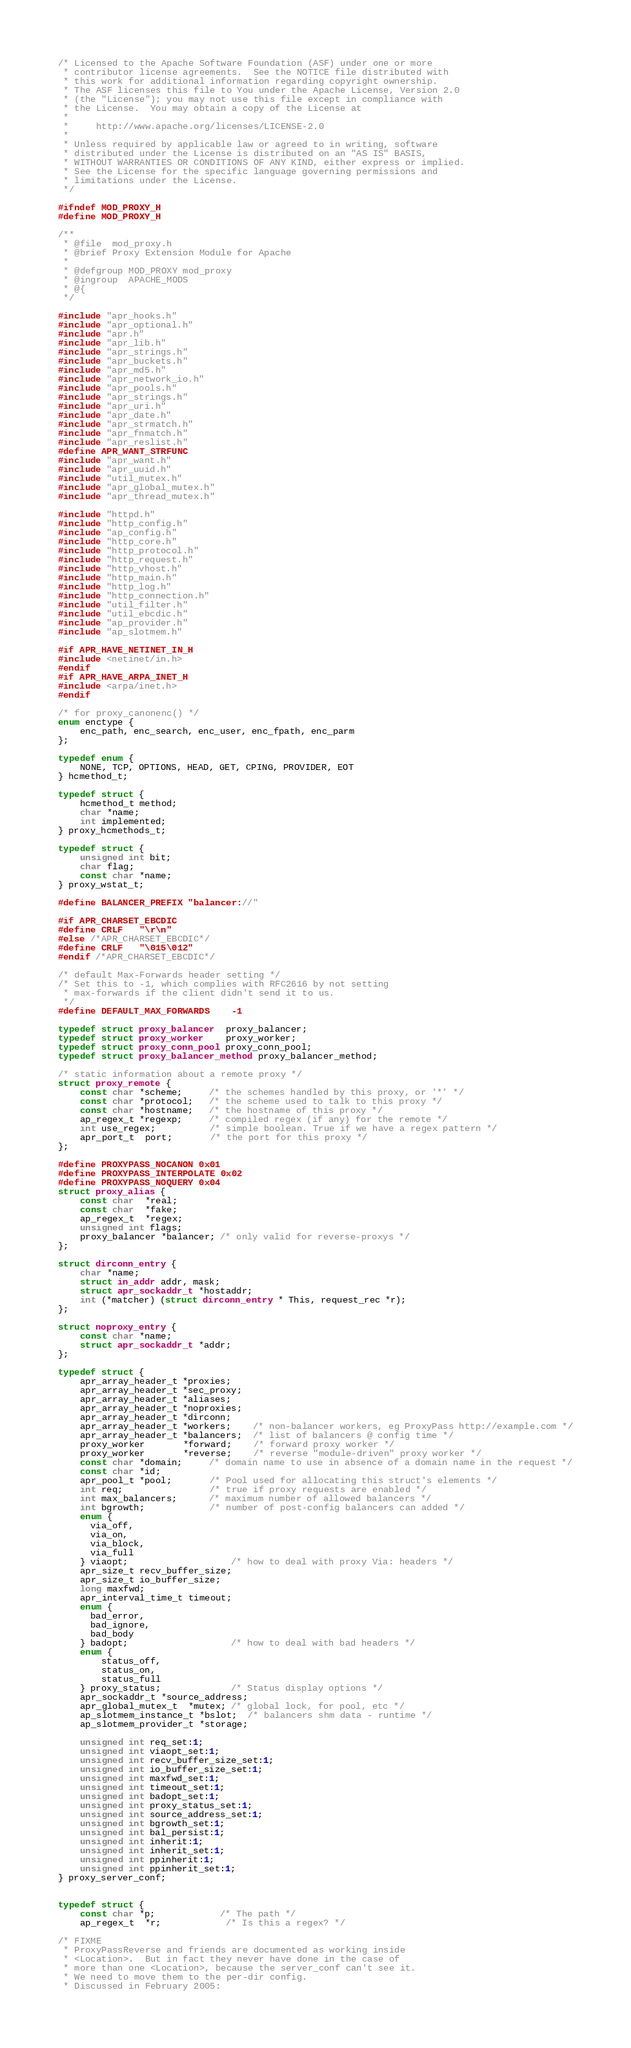Convert code to text. <code><loc_0><loc_0><loc_500><loc_500><_C_>/* Licensed to the Apache Software Foundation (ASF) under one or more
 * contributor license agreements.  See the NOTICE file distributed with
 * this work for additional information regarding copyright ownership.
 * The ASF licenses this file to You under the Apache License, Version 2.0
 * (the "License"); you may not use this file except in compliance with
 * the License.  You may obtain a copy of the License at
 *
 *     http://www.apache.org/licenses/LICENSE-2.0
 *
 * Unless required by applicable law or agreed to in writing, software
 * distributed under the License is distributed on an "AS IS" BASIS,
 * WITHOUT WARRANTIES OR CONDITIONS OF ANY KIND, either express or implied.
 * See the License for the specific language governing permissions and
 * limitations under the License.
 */

#ifndef MOD_PROXY_H
#define MOD_PROXY_H

/**
 * @file  mod_proxy.h
 * @brief Proxy Extension Module for Apache
 *
 * @defgroup MOD_PROXY mod_proxy
 * @ingroup  APACHE_MODS
 * @{
 */

#include "apr_hooks.h"
#include "apr_optional.h"
#include "apr.h"
#include "apr_lib.h"
#include "apr_strings.h"
#include "apr_buckets.h"
#include "apr_md5.h"
#include "apr_network_io.h"
#include "apr_pools.h"
#include "apr_strings.h"
#include "apr_uri.h"
#include "apr_date.h"
#include "apr_strmatch.h"
#include "apr_fnmatch.h"
#include "apr_reslist.h"
#define APR_WANT_STRFUNC
#include "apr_want.h"
#include "apr_uuid.h"
#include "util_mutex.h"
#include "apr_global_mutex.h"
#include "apr_thread_mutex.h"

#include "httpd.h"
#include "http_config.h"
#include "ap_config.h"
#include "http_core.h"
#include "http_protocol.h"
#include "http_request.h"
#include "http_vhost.h"
#include "http_main.h"
#include "http_log.h"
#include "http_connection.h"
#include "util_filter.h"
#include "util_ebcdic.h"
#include "ap_provider.h"
#include "ap_slotmem.h"

#if APR_HAVE_NETINET_IN_H
#include <netinet/in.h>
#endif
#if APR_HAVE_ARPA_INET_H
#include <arpa/inet.h>
#endif

/* for proxy_canonenc() */
enum enctype {
    enc_path, enc_search, enc_user, enc_fpath, enc_parm
};

typedef enum {
    NONE, TCP, OPTIONS, HEAD, GET, CPING, PROVIDER, EOT
} hcmethod_t;

typedef struct {
    hcmethod_t method;
    char *name;
    int implemented;
} proxy_hcmethods_t;

typedef struct {
    unsigned int bit;
    char flag;
    const char *name;
} proxy_wstat_t;

#define BALANCER_PREFIX "balancer://"

#if APR_CHARSET_EBCDIC
#define CRLF   "\r\n"
#else /*APR_CHARSET_EBCDIC*/
#define CRLF   "\015\012"
#endif /*APR_CHARSET_EBCDIC*/

/* default Max-Forwards header setting */
/* Set this to -1, which complies with RFC2616 by not setting
 * max-forwards if the client didn't send it to us.
 */
#define DEFAULT_MAX_FORWARDS    -1

typedef struct proxy_balancer  proxy_balancer;
typedef struct proxy_worker    proxy_worker;
typedef struct proxy_conn_pool proxy_conn_pool;
typedef struct proxy_balancer_method proxy_balancer_method;

/* static information about a remote proxy */
struct proxy_remote {
    const char *scheme;     /* the schemes handled by this proxy, or '*' */
    const char *protocol;   /* the scheme used to talk to this proxy */
    const char *hostname;   /* the hostname of this proxy */
    ap_regex_t *regexp;     /* compiled regex (if any) for the remote */
    int use_regex;          /* simple boolean. True if we have a regex pattern */
    apr_port_t  port;       /* the port for this proxy */
};

#define PROXYPASS_NOCANON 0x01
#define PROXYPASS_INTERPOLATE 0x02
#define PROXYPASS_NOQUERY 0x04
struct proxy_alias {
    const char  *real;
    const char  *fake;
    ap_regex_t  *regex;
    unsigned int flags;
    proxy_balancer *balancer; /* only valid for reverse-proxys */
};

struct dirconn_entry {
    char *name;
    struct in_addr addr, mask;
    struct apr_sockaddr_t *hostaddr;
    int (*matcher) (struct dirconn_entry * This, request_rec *r);
};

struct noproxy_entry {
    const char *name;
    struct apr_sockaddr_t *addr;
};

typedef struct {
    apr_array_header_t *proxies;
    apr_array_header_t *sec_proxy;
    apr_array_header_t *aliases;
    apr_array_header_t *noproxies;
    apr_array_header_t *dirconn;
    apr_array_header_t *workers;    /* non-balancer workers, eg ProxyPass http://example.com */
    apr_array_header_t *balancers;  /* list of balancers @ config time */
    proxy_worker       *forward;    /* forward proxy worker */
    proxy_worker       *reverse;    /* reverse "module-driven" proxy worker */
    const char *domain;     /* domain name to use in absence of a domain name in the request */
    const char *id;
    apr_pool_t *pool;       /* Pool used for allocating this struct's elements */
    int req;                /* true if proxy requests are enabled */
    int max_balancers;      /* maximum number of allowed balancers */
    int bgrowth;            /* number of post-config balancers can added */
    enum {
      via_off,
      via_on,
      via_block,
      via_full
    } viaopt;                   /* how to deal with proxy Via: headers */
    apr_size_t recv_buffer_size;
    apr_size_t io_buffer_size;
    long maxfwd;
    apr_interval_time_t timeout;
    enum {
      bad_error,
      bad_ignore,
      bad_body
    } badopt;                   /* how to deal with bad headers */
    enum {
        status_off,
        status_on,
        status_full
    } proxy_status;             /* Status display options */
    apr_sockaddr_t *source_address;
    apr_global_mutex_t  *mutex; /* global lock, for pool, etc */
    ap_slotmem_instance_t *bslot;  /* balancers shm data - runtime */
    ap_slotmem_provider_t *storage;

    unsigned int req_set:1;
    unsigned int viaopt_set:1;
    unsigned int recv_buffer_size_set:1;
    unsigned int io_buffer_size_set:1;
    unsigned int maxfwd_set:1;
    unsigned int timeout_set:1;
    unsigned int badopt_set:1;
    unsigned int proxy_status_set:1;
    unsigned int source_address_set:1;
    unsigned int bgrowth_set:1;
    unsigned int bal_persist:1;
    unsigned int inherit:1;
    unsigned int inherit_set:1;
    unsigned int ppinherit:1;
    unsigned int ppinherit_set:1;
} proxy_server_conf;


typedef struct {
    const char *p;            /* The path */
    ap_regex_t  *r;            /* Is this a regex? */

/* FIXME
 * ProxyPassReverse and friends are documented as working inside
 * <Location>.  But in fact they never have done in the case of
 * more than one <Location>, because the server_conf can't see it.
 * We need to move them to the per-dir config.
 * Discussed in February 2005:</code> 